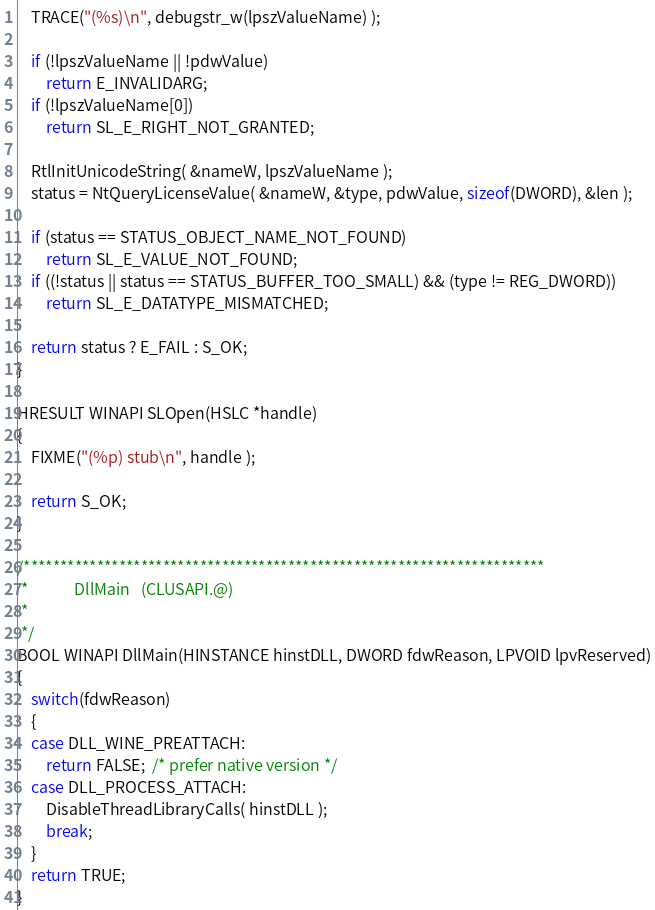Convert code to text. <code><loc_0><loc_0><loc_500><loc_500><_C_>    TRACE("(%s)\n", debugstr_w(lpszValueName) );

    if (!lpszValueName || !pdwValue)
        return E_INVALIDARG;
    if (!lpszValueName[0])
        return SL_E_RIGHT_NOT_GRANTED;

    RtlInitUnicodeString( &nameW, lpszValueName );
    status = NtQueryLicenseValue( &nameW, &type, pdwValue, sizeof(DWORD), &len );

    if (status == STATUS_OBJECT_NAME_NOT_FOUND)
        return SL_E_VALUE_NOT_FOUND;
    if ((!status || status == STATUS_BUFFER_TOO_SMALL) && (type != REG_DWORD))
        return SL_E_DATATYPE_MISMATCHED;

    return status ? E_FAIL : S_OK;
}

HRESULT WINAPI SLOpen(HSLC *handle)
{
    FIXME("(%p) stub\n", handle );

    return S_OK;
}

/***********************************************************************
 *             DllMain   (CLUSAPI.@)
 *
 */
BOOL WINAPI DllMain(HINSTANCE hinstDLL, DWORD fdwReason, LPVOID lpvReserved)
{
    switch(fdwReason)
    {
    case DLL_WINE_PREATTACH:
        return FALSE;  /* prefer native version */
    case DLL_PROCESS_ATTACH:
        DisableThreadLibraryCalls( hinstDLL );
        break;
    }
    return TRUE;
}
</code> 